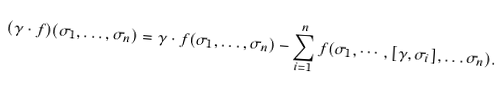Convert formula to latex. <formula><loc_0><loc_0><loc_500><loc_500>( \gamma \cdot f ) ( \sigma _ { 1 } , \dots , \sigma _ { n } ) = \gamma \cdot f ( \sigma _ { 1 } , \dots , \sigma _ { n } ) - \sum _ { i = 1 } ^ { n } f ( \sigma _ { 1 } , \cdots , [ \gamma , \sigma _ { i } ] , \dots \sigma _ { n } ) .</formula> 